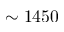Convert formula to latex. <formula><loc_0><loc_0><loc_500><loc_500>\sim 1 4 5 0</formula> 